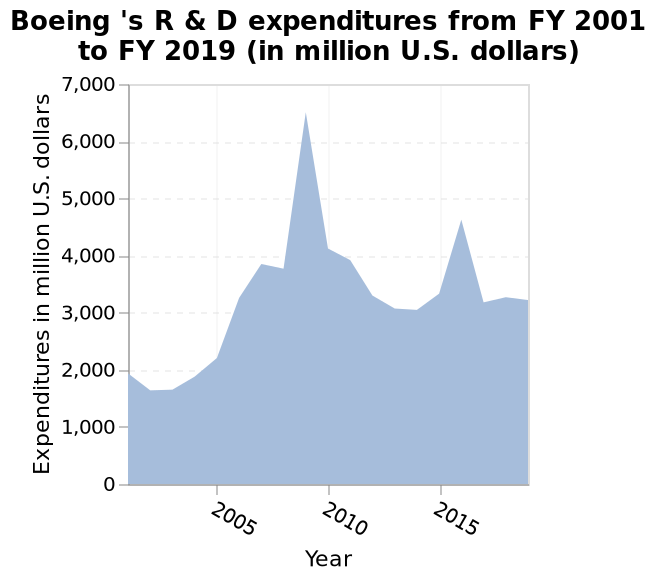<image>
please enumerates aspects of the construction of the chart Here a is a area plot called Boeing 's R & D expenditures from FY 2001 to FY 2019 (in million U.S. dollars). Year is plotted along the x-axis. On the y-axis, Expenditures in million U.S. dollars is measured on a linear scale from 0 to 7,000. When did Boeing experience a large spike in R&D expenditure? Boeing experienced a large spike in R&D expenditure in 2009. What is the unit used to measure the expenditures? The expenditures are measured in million U.S. dollars. What is the name of the area plot?  The area plot is called Boeing's R & D expenditures. 